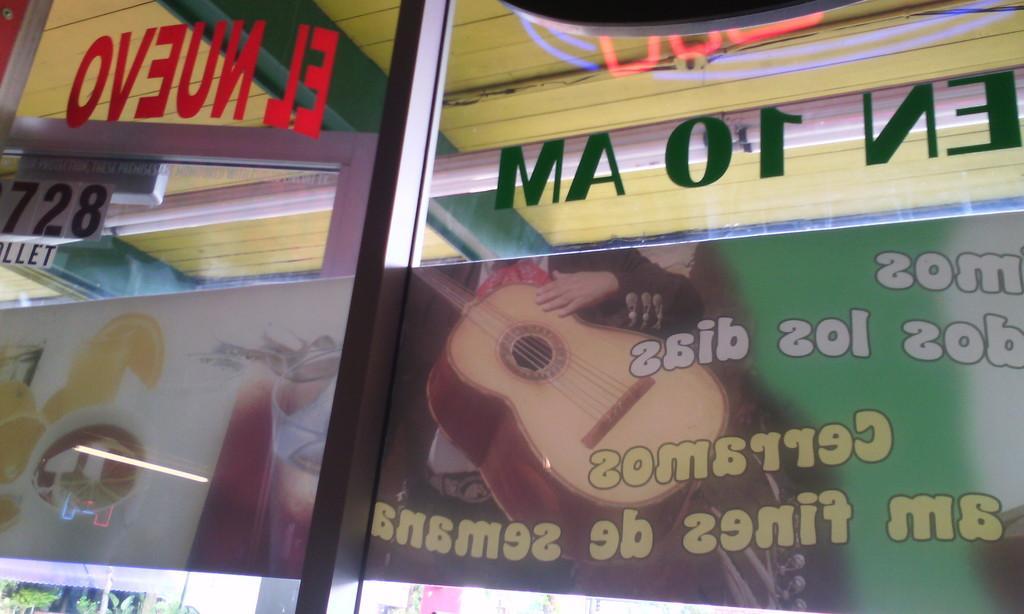How would you summarize this image in a sentence or two? In this picture, we see a glass door on which some posts are posted. We see some text written on the poster. We even see some text written on the glass. In the background, we see a wall in yellow color. 